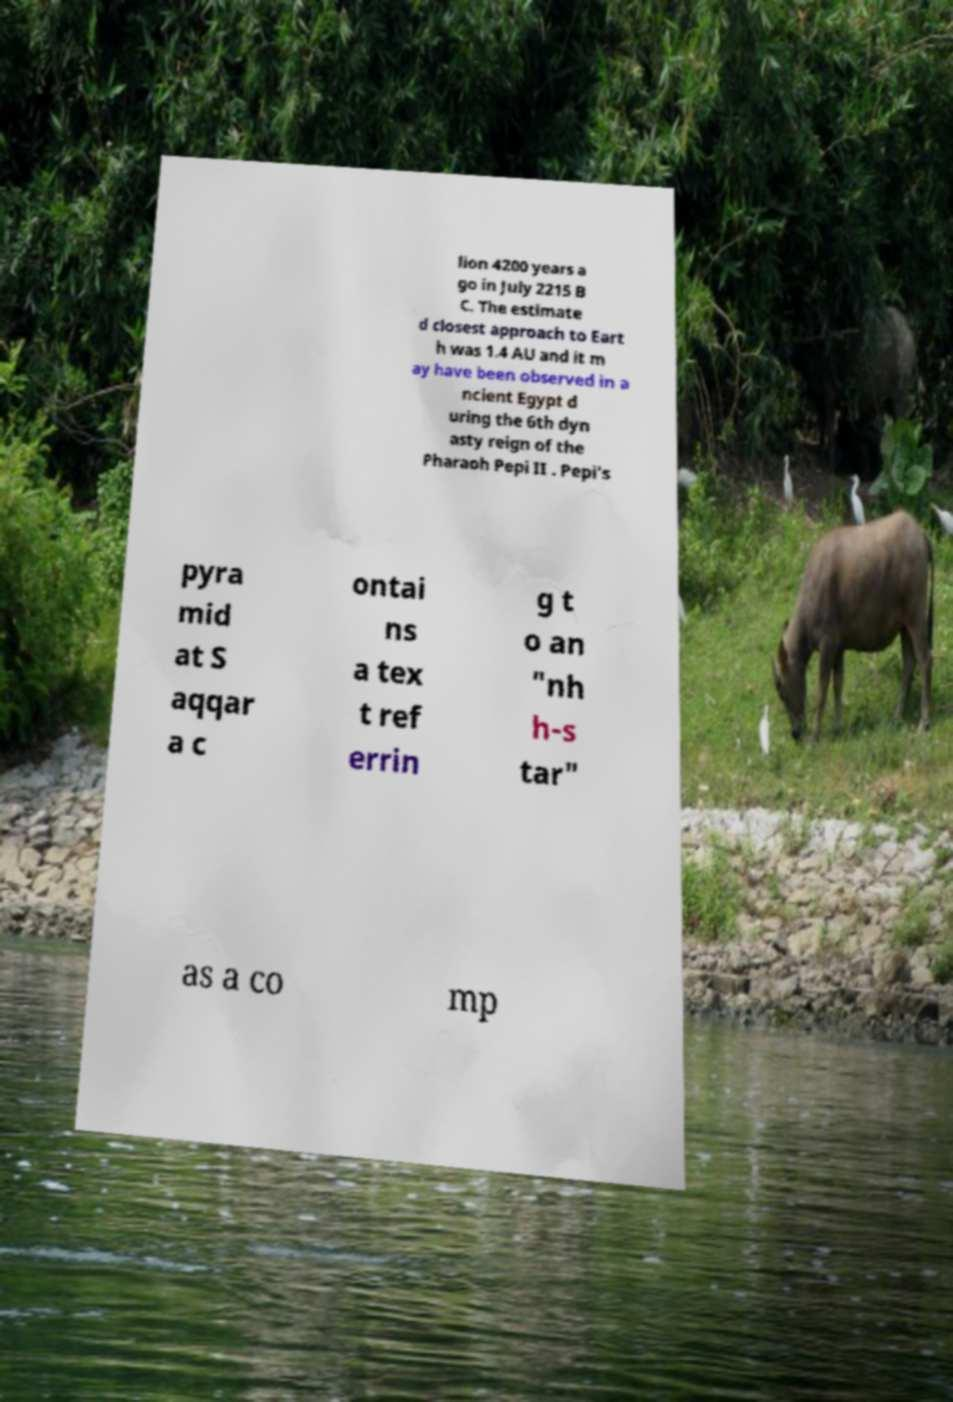Could you extract and type out the text from this image? lion 4200 years a go in July 2215 B C. The estimate d closest approach to Eart h was 1.4 AU and it m ay have been observed in a ncient Egypt d uring the 6th dyn asty reign of the Pharaoh Pepi II . Pepi's pyra mid at S aqqar a c ontai ns a tex t ref errin g t o an "nh h-s tar" as a co mp 